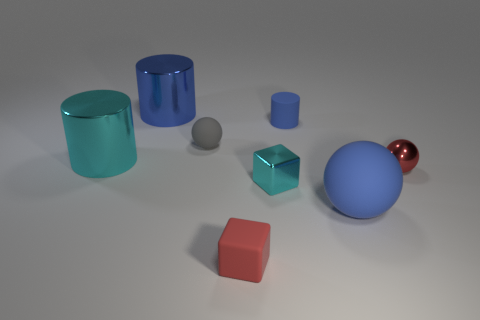The metal cylinder that is the same color as the small shiny block is what size?
Your response must be concise. Large. There is a small cylinder that is the same color as the big ball; what is it made of?
Your response must be concise. Rubber. Do the big sphere and the small rubber cylinder have the same color?
Offer a terse response. Yes. The large shiny object behind the ball that is on the left side of the small blue matte cylinder that is right of the blue metallic thing is what shape?
Offer a very short reply. Cylinder. What is the shape of the gray rubber object?
Offer a very short reply. Sphere. What shape is the red shiny thing that is the same size as the metal block?
Keep it short and to the point. Sphere. What number of other objects are there of the same color as the small matte ball?
Offer a very short reply. 0. There is a red object right of the small red rubber cube; is its shape the same as the metallic object that is behind the gray sphere?
Keep it short and to the point. No. What number of things are small rubber objects right of the gray matte thing or small rubber things right of the tiny cyan metallic object?
Your answer should be compact. 2. What number of other objects are there of the same material as the cyan cylinder?
Offer a very short reply. 3. 